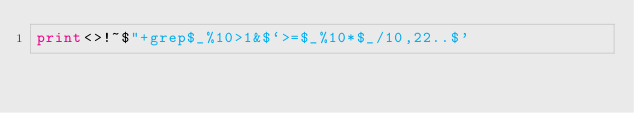<code> <loc_0><loc_0><loc_500><loc_500><_Perl_>print<>!~$"+grep$_%10>1&$`>=$_%10*$_/10,22..$'</code> 